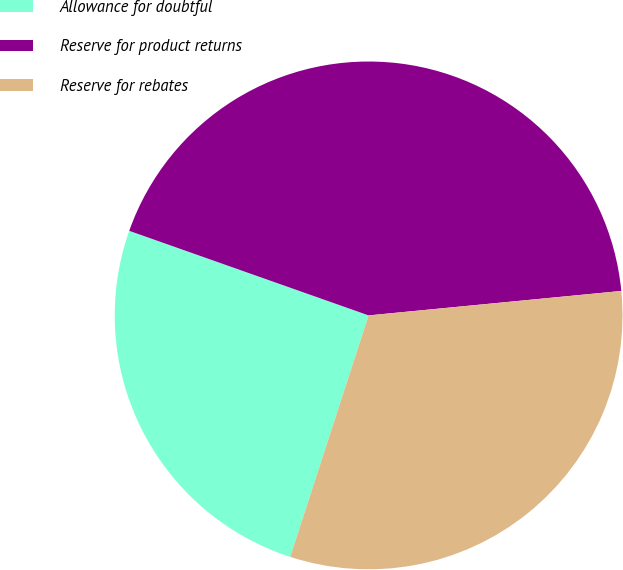Convert chart. <chart><loc_0><loc_0><loc_500><loc_500><pie_chart><fcel>Allowance for doubtful<fcel>Reserve for product returns<fcel>Reserve for rebates<nl><fcel>25.41%<fcel>43.06%<fcel>31.53%<nl></chart> 